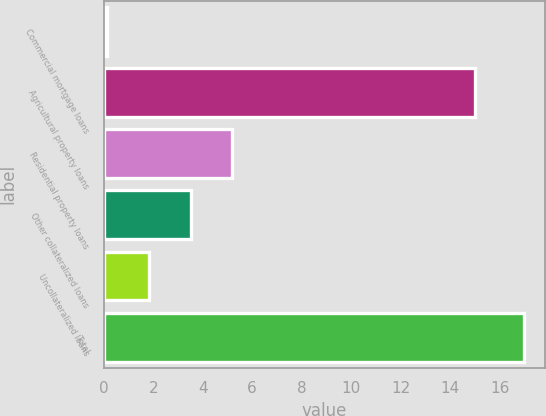Convert chart. <chart><loc_0><loc_0><loc_500><loc_500><bar_chart><fcel>Commercial mortgage loans<fcel>Agricultural property loans<fcel>Residential property loans<fcel>Other collateralized loans<fcel>Uncollateralized loans<fcel>Total<nl><fcel>0.13<fcel>15<fcel>5.2<fcel>3.51<fcel>1.82<fcel>17<nl></chart> 